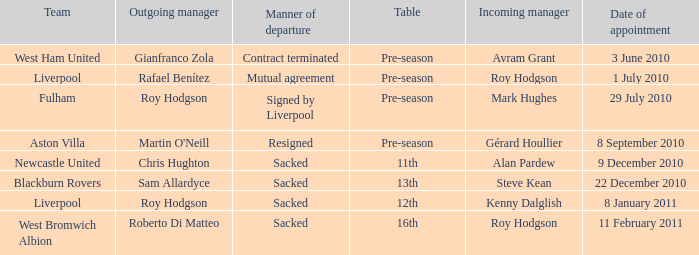What is the date of vacancy for the Liverpool team with a table named pre-season? 3 June 2010. 